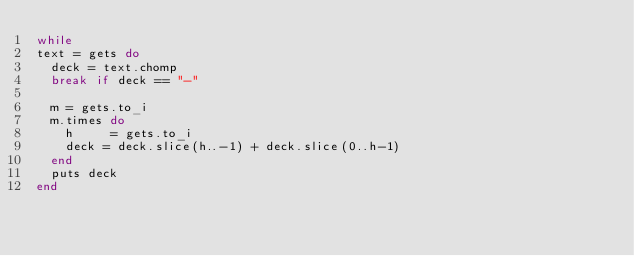Convert code to text. <code><loc_0><loc_0><loc_500><loc_500><_Ruby_>while
text = gets do
  deck = text.chomp
  break if deck == "-"
  
  m = gets.to_i
  m.times do
    h     = gets.to_i
    deck = deck.slice(h..-1) + deck.slice(0..h-1)
  end
  puts deck
end</code> 